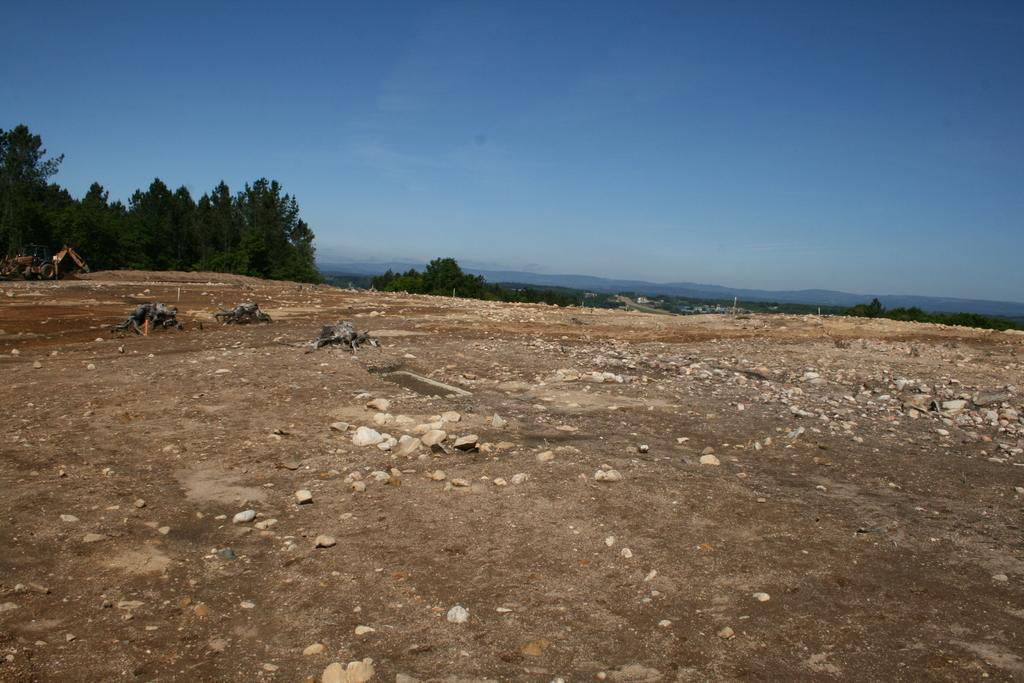What type of terrain is visible in the image? There is ground with stones in the image. What can be seen behind the ground in the image? There are trees behind the ground in the image. What is located behind the trees in the image? There are mountains behind the trees in the image. What color is the sky in the image? The sky is blue and visible at the top of the image. What type of pen is being used to draw the mountains in the image? There is no pen or drawing in the image; it is a photograph of a natural landscape. 